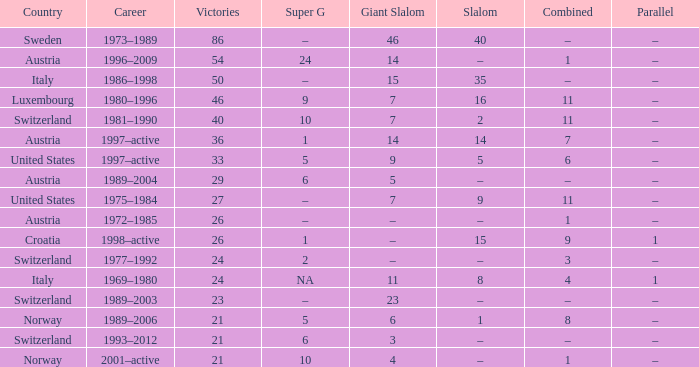What Super G has Victories of 26, and a Country of austria? –. 